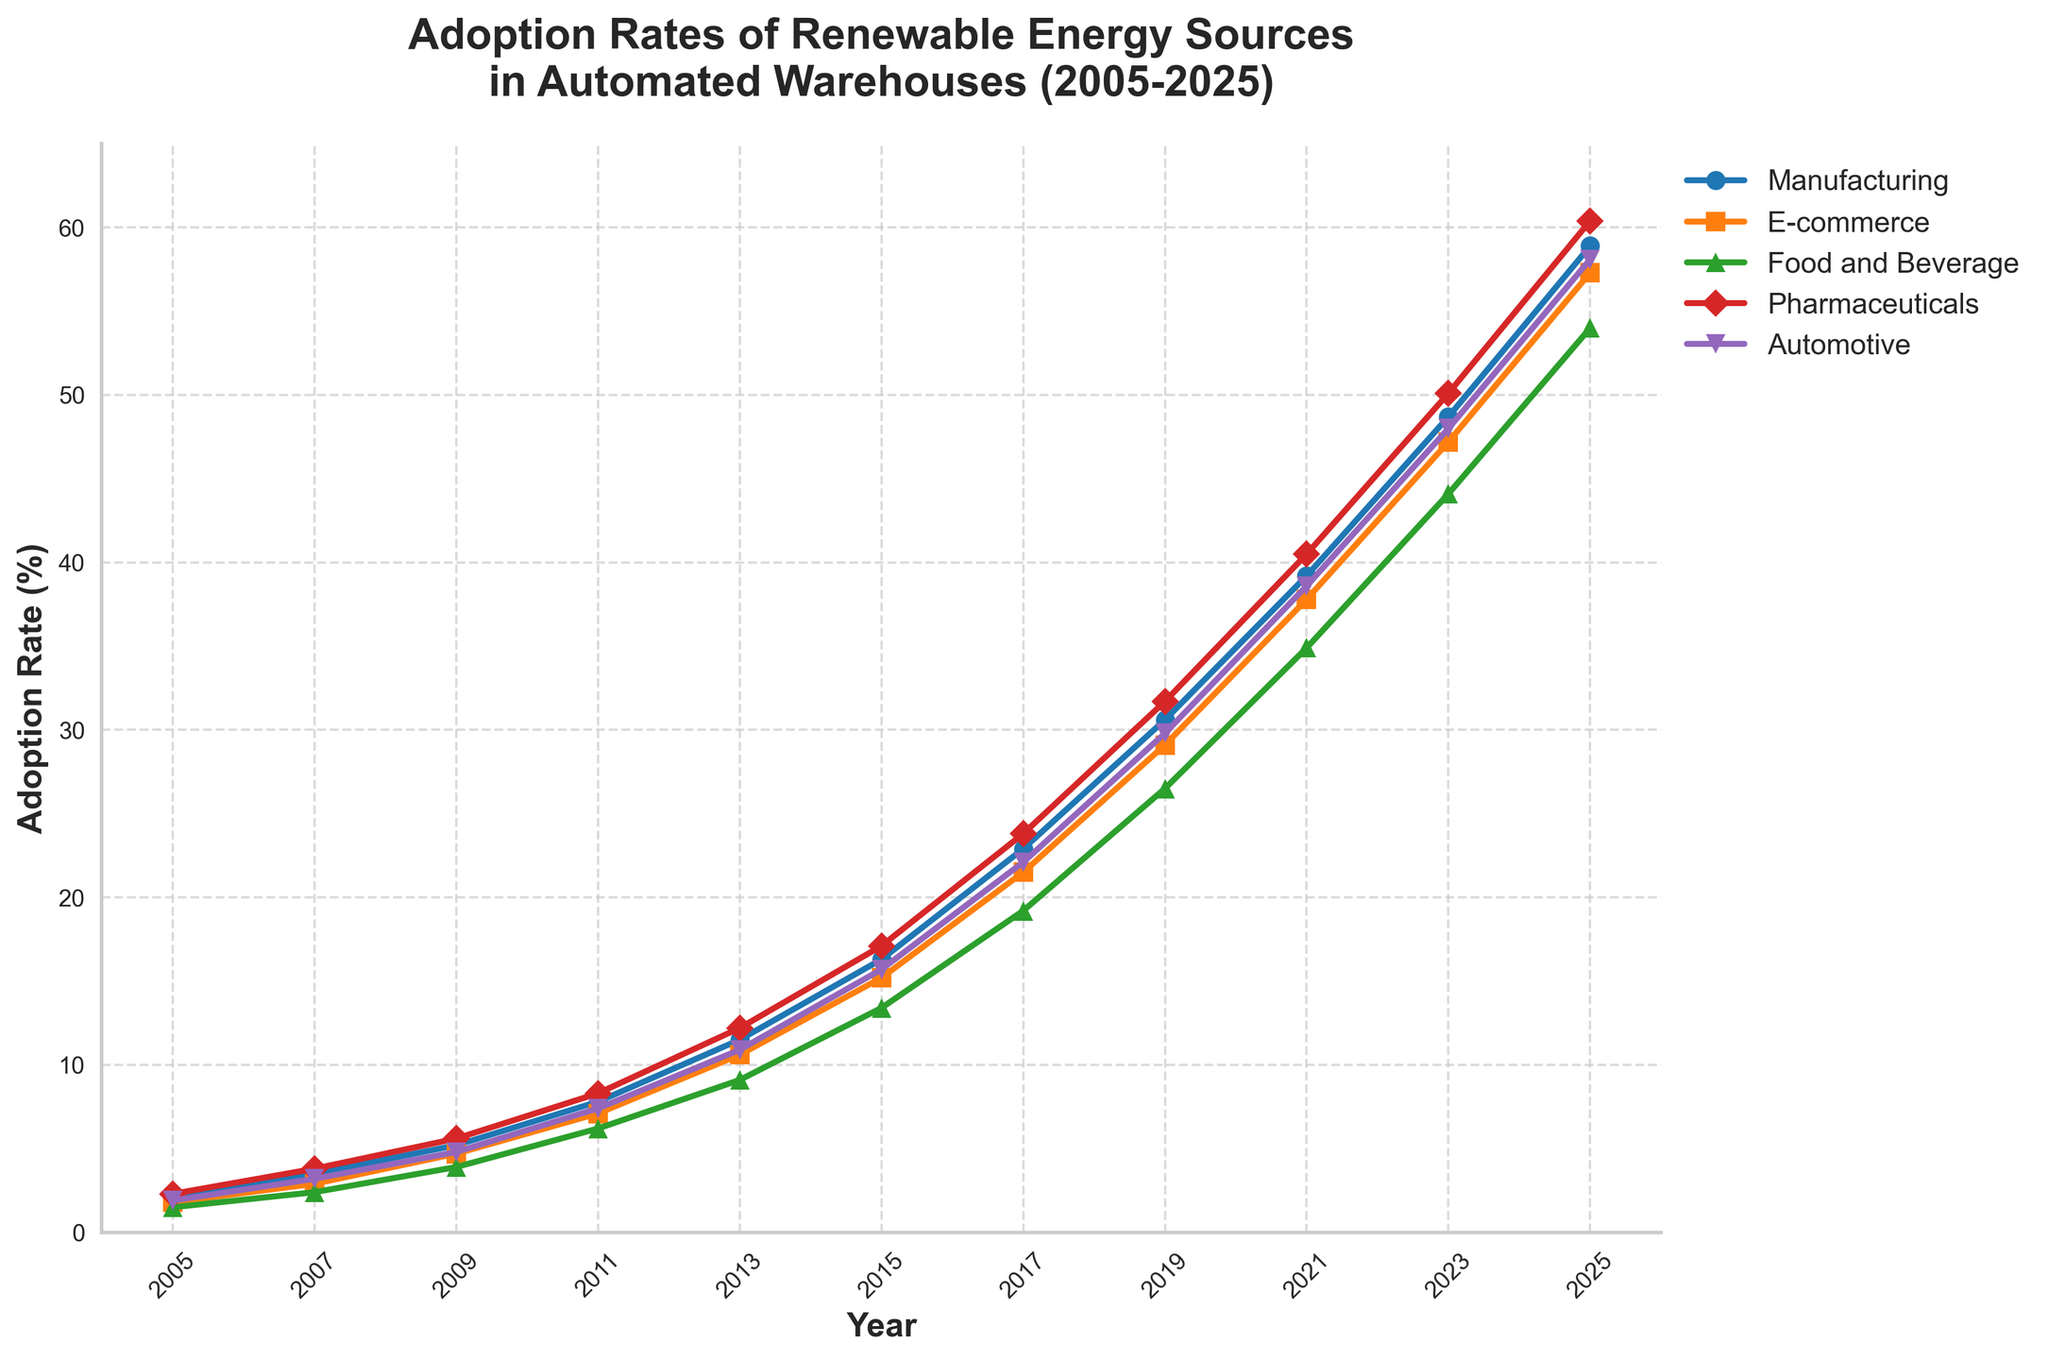What's the average adoption rate of renewable energy in automated e-commerce warehouses for the years 2005, 2015, and 2025? To find the average, sum the values for the years 2005 (1.8), 2015 (15.2), and 2025 (57.3), then divide by 3. So, (1.8 + 15.2 + 57.3) / 3 = 24.77.
Answer: 24.77 Which industry has the highest adoption rate of renewable energy in automated warehouses in 2025? Look at the y-axis value for the year 2025 for each industry and identify the highest value. Pharmaceuticals in 2025 have the highest value at 60.4.
Answer: Pharmaceuticals Between 2009 and 2015, which industry experienced the greatest increase in adoption rate for renewable energy in automated warehouses? Calculate the difference between 2015 and 2009 for each industry: Manufacturing (16.3 - 5.2 = 11.1), E-commerce (15.2 - 4.7 = 10.5), Food and Beverage (13.4 - 3.9 = 9.5), Pharmaceuticals (17.1 - 5.6 = 11.5), and Automotive (15.7 - 4.8 = 10.9). Pharmaceuticals have the greatest increase (11.5).
Answer: Pharmaceuticals In which year did the adoption rate of renewable energy in automated warehouses for the automotive industry first exceed 20%? Trace the line for the automotive industry and check the year where the value first exceeds 20%. This occurs between 2015 (15.7) and 2017 (22.1), so it first exceeds 20% in 2017.
Answer: 2017 What is the difference in adoption rates between the manufacturing and food and beverage industries in 2023? Subtract the adoption rate of the food and beverage industry (44.1) from the manufacturing industry (48.7) in 2023. So, 48.7 - 44.1 = 4.6.
Answer: 4.6 By how much did the adoption rate of renewable energy in automated warehouses for the pharmaceutical industry increase between 2011 and 2019? Subtract the adoption rate in 2011 (8.3) from the adoption rate in 2019 (31.7). So, 31.7 - 8.3 = 23.4.
Answer: 23.4 Between 2005 and 2025, which industry has exhibited the most consistent (steady) increase in the adoption rate of renewable energy in automated warehouses? Observe the slope and overall trend of the lines for each industry across the years. The e-commerce industry shows a relatively steady and consistent increase over the years.
Answer: E-commerce Determine the average annual increase in the adoption rate of renewable energy for the food and beverage industry from 2005 to 2025. Calculate the total increase from 2005 (1.5) to 2025 (54.0) which is 54.0 - 1.5 = 52.5. Then, divide this increase by the number of years (2025 - 2005 = 20 years). So, 52.5 / 20 = 2.625.
Answer: 2.625 Which two industries had the closest adoption rates of renewable energy in automated warehouses in 2007? Compare the adoption rates for 2007: Manufacturing (3.5), E-commerce (2.9), Food and Beverage (2.4), Pharmaceuticals (3.8), Automotive (3.2). The closest are Manufacturing (3.5) and Automotive (3.2).
Answer: Manufacturing and Automotive 